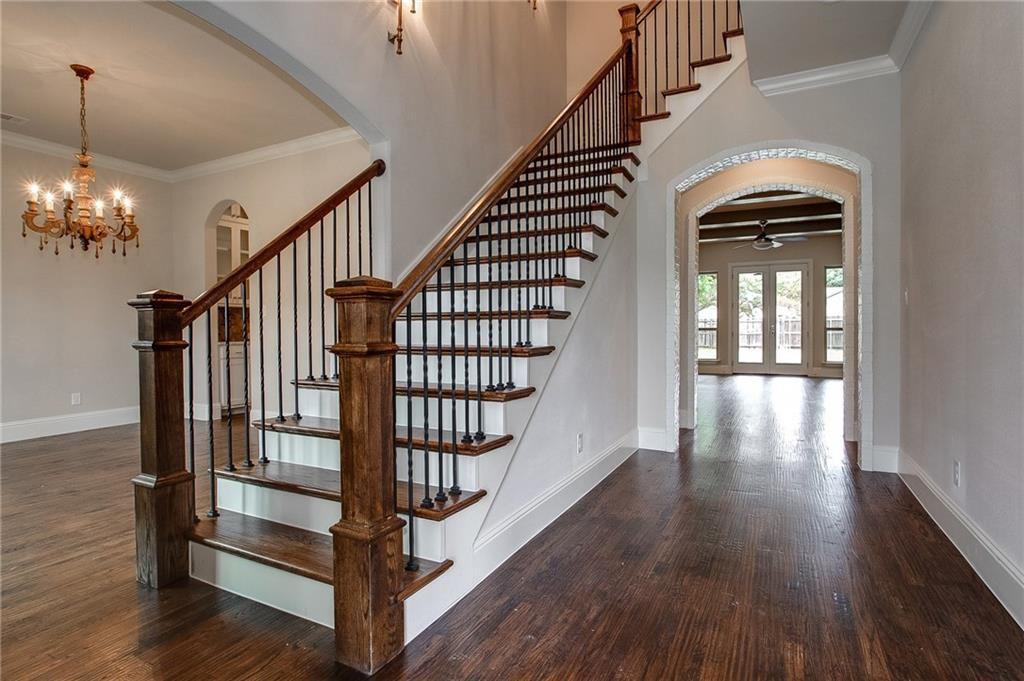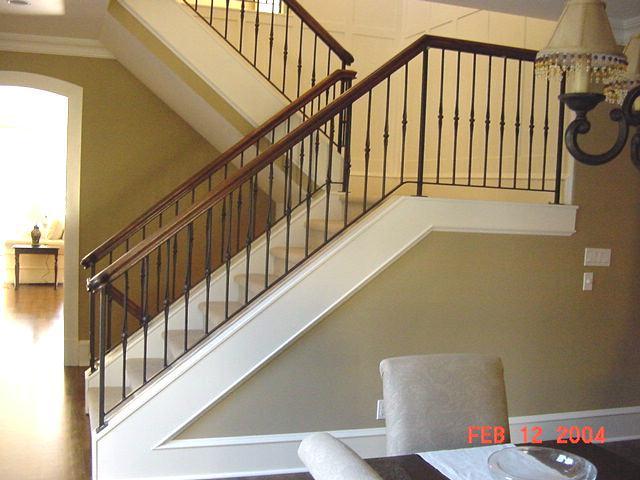The first image is the image on the left, the second image is the image on the right. Examine the images to the left and right. Is the description "An image shows a staircase that ascends rightward next to an arch doorway, and the staircase has wooden steps with white base boards." accurate? Answer yes or no. Yes. 